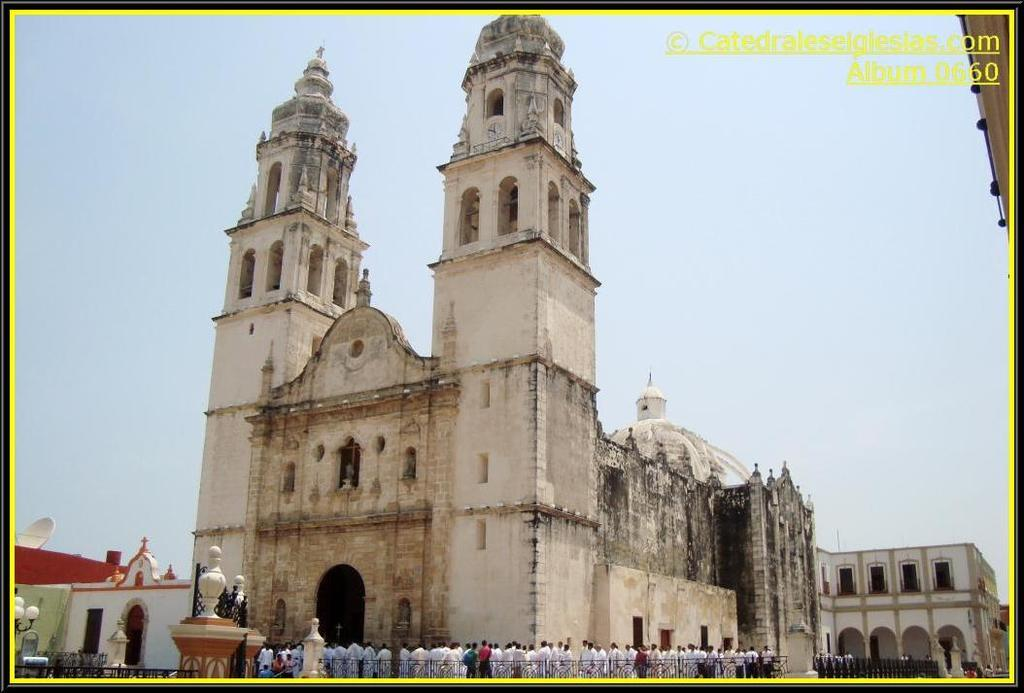What is the main subject of the image? The main subject of the image is a crowd. Where is the crowd located in relation to another structure? The crowd is in front of a fort. What can be seen in the background of the image? There is a sky visible in the background of the image. What type of base can be seen supporting the crowd in the image? There is no base supporting the crowd in the image; they are standing on the ground. 